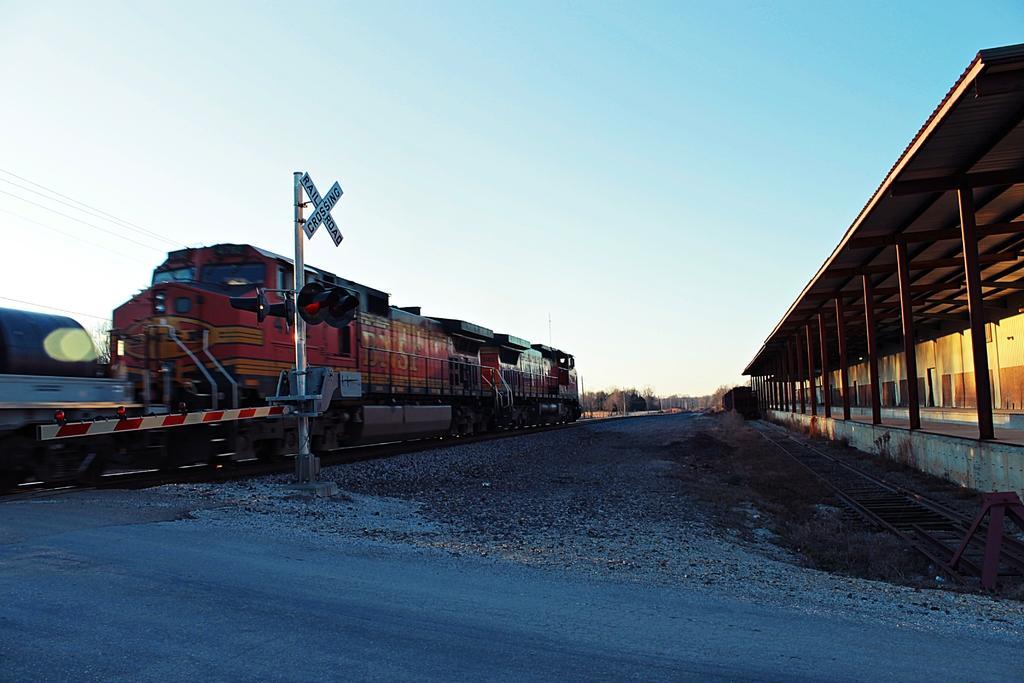In one or two sentences, can you explain what this image depicts? In the picture I can see trains on railway tracks. I can also see poles, roofs, wires attached to poles and some other objects on the ground. In the background I can see trees and the sky. 